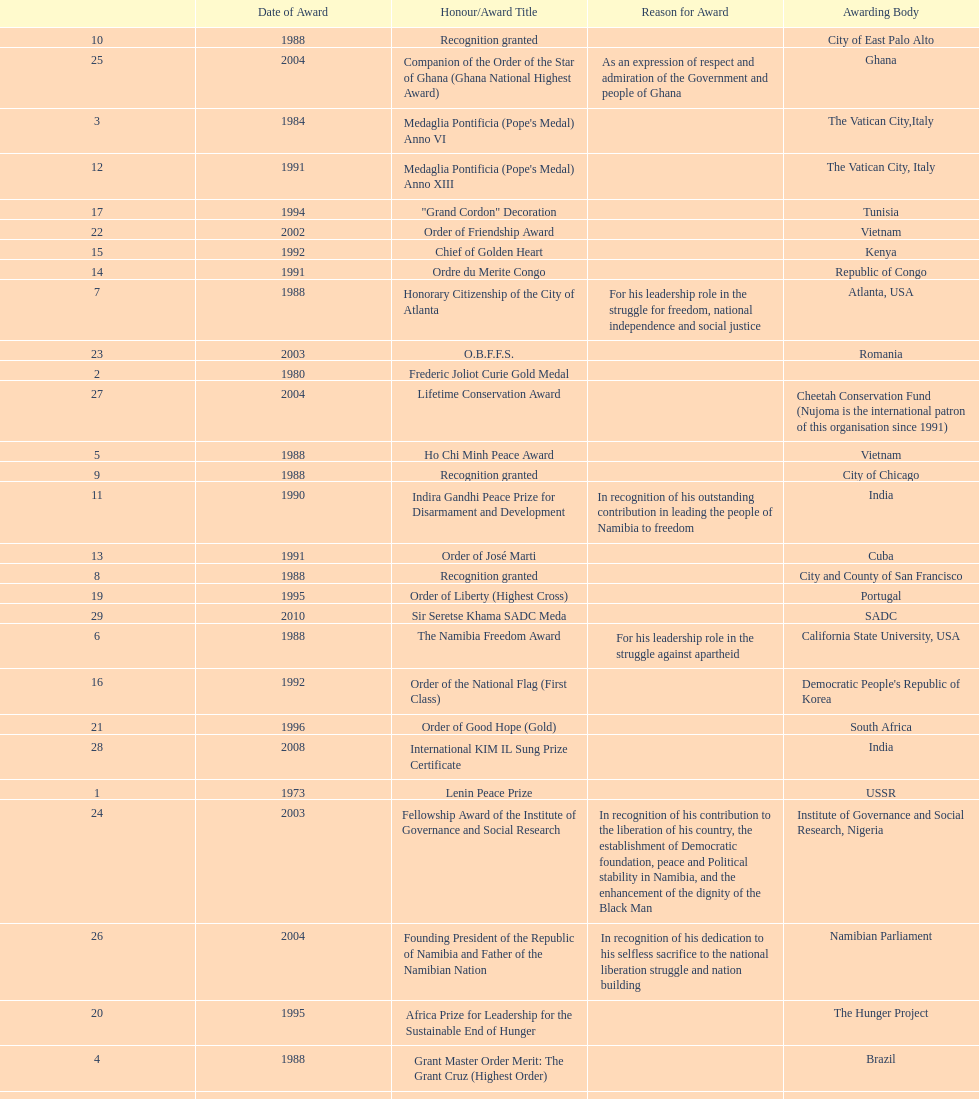The "fellowship award of the institute of governance and social research" was awarded in 2003 or 2004? 2003. 